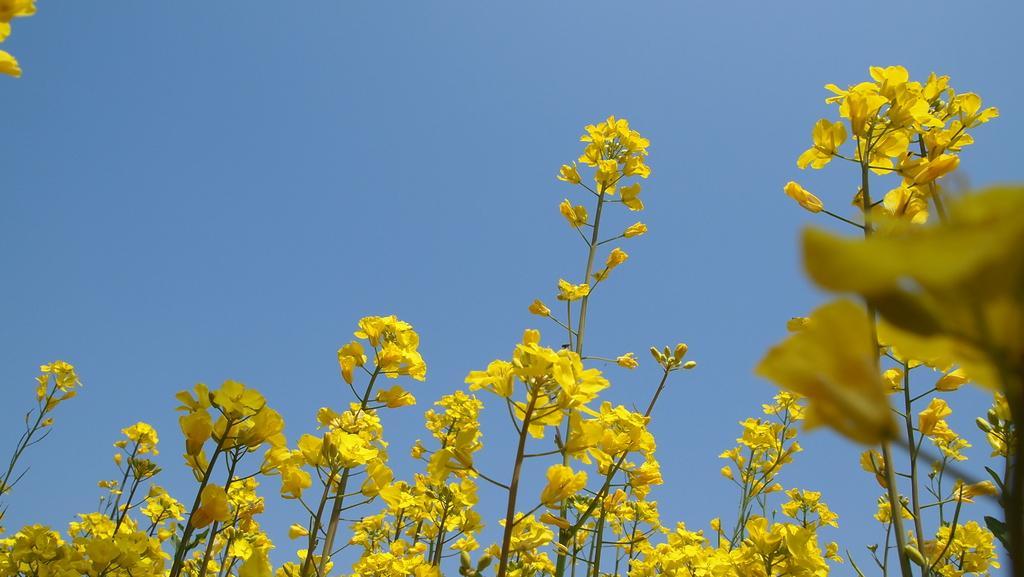Could you give a brief overview of what you see in this image? In this image, we can see some flowers on the blue background. 